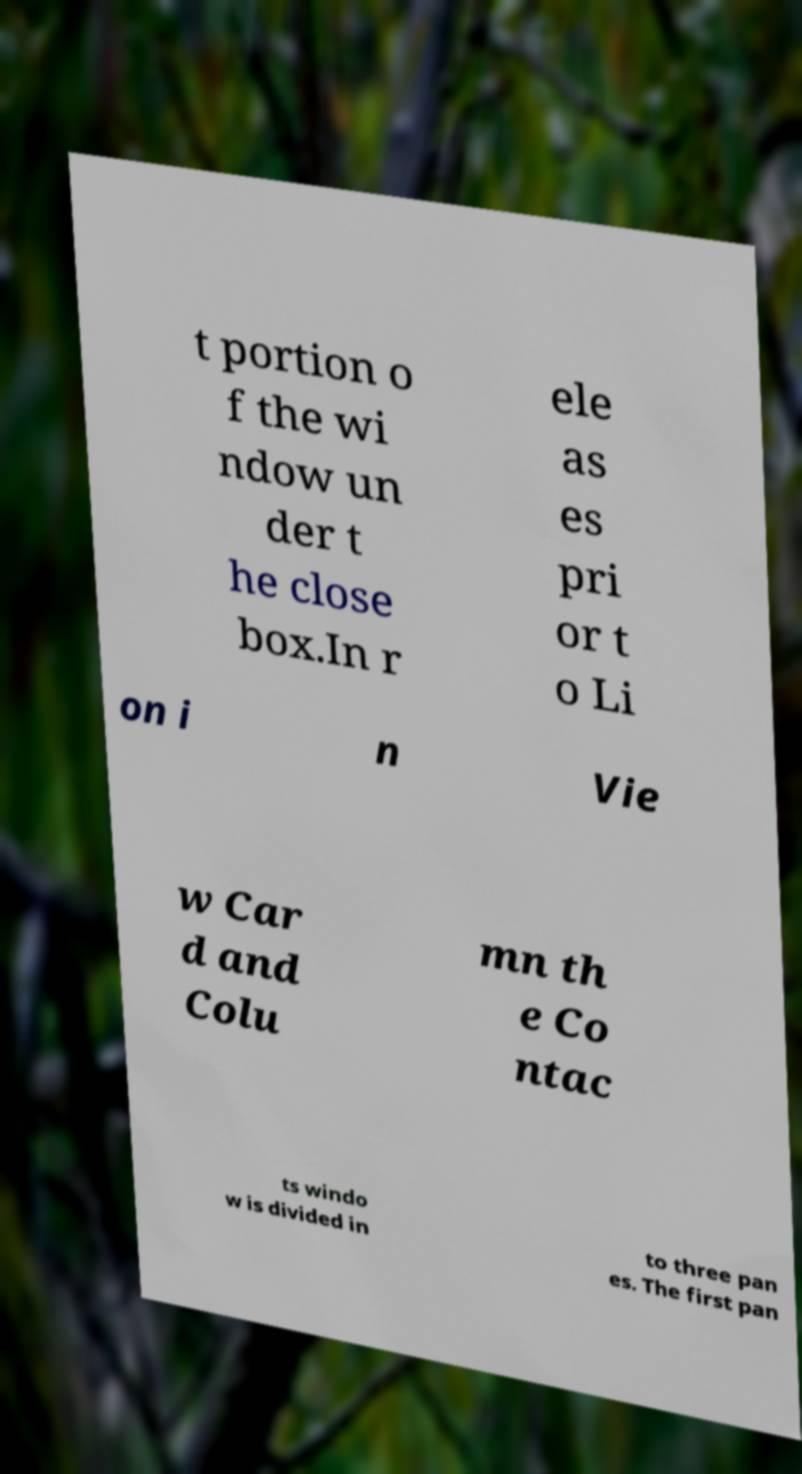Could you extract and type out the text from this image? t portion o f the wi ndow un der t he close box.In r ele as es pri or t o Li on i n Vie w Car d and Colu mn th e Co ntac ts windo w is divided in to three pan es. The first pan 